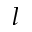<formula> <loc_0><loc_0><loc_500><loc_500>l</formula> 